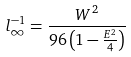Convert formula to latex. <formula><loc_0><loc_0><loc_500><loc_500>l _ { \infty } ^ { - 1 } = \frac { W ^ { 2 } } { 9 6 \left ( 1 - \frac { E ^ { 2 } } { 4 } \right ) }</formula> 